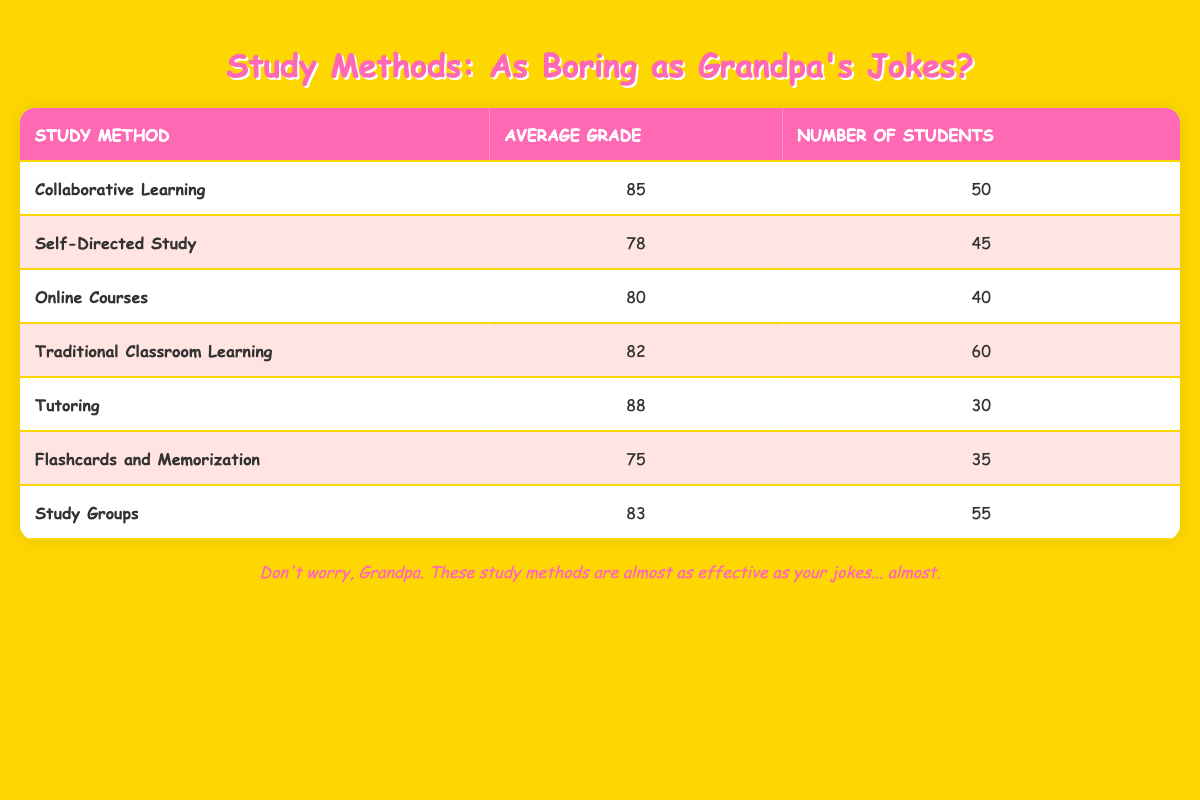What is the average grade for Tutoring? The table shows that the average grade for Tutoring is listed as 88.
Answer: 88 Which study method has the highest number of students? By reviewing the number of students for each method in the table, Traditional Classroom Learning has the highest with 60 students.
Answer: Traditional Classroom Learning How many students used self-directed study? The table indicates that 45 students used the Self-Directed Study method.
Answer: 45 What is the difference between the average grades of Tutoring and Flashcards and Memorization? Tutoring has an average grade of 88, while Flashcards and Memorization has an average grade of 75. The difference is 88 - 75 = 13.
Answer: 13 Is the average grade for Online Courses greater than the average grade for Self-Directed Study? The average grade for Online Courses is 80, and for Self-Directed Study, it is 78. Since 80 is greater than 78, the statement is true.
Answer: Yes What is the average grade of Study Groups and Online Courses combined? The average grade for Study Groups is 83 and for Online Courses is 80. To find the combined average, we first sum the two grades (83 + 80 = 163) and then divide by 2, giving us 163 / 2 = 81.5.
Answer: 81.5 Which study method had the lowest average grade? By examining the table, Flashcards and Memorization has the lowest average grade of 75 when compared with other study methods.
Answer: Flashcards and Memorization What is the total number of students across all study methods? We add the number of students from each method: 50 + 45 + 40 + 60 + 30 + 35 + 55 = 315. Thus, the total number of students is 315.
Answer: 315 How does the average grade for Study Groups compare to Traditional Classroom Learning? The average grade for Study Groups is 83 and for Traditional Classroom Learning is 82. Since 83 is greater than 82, Study Groups have a higher average grade.
Answer: Study Groups have a higher average grade 